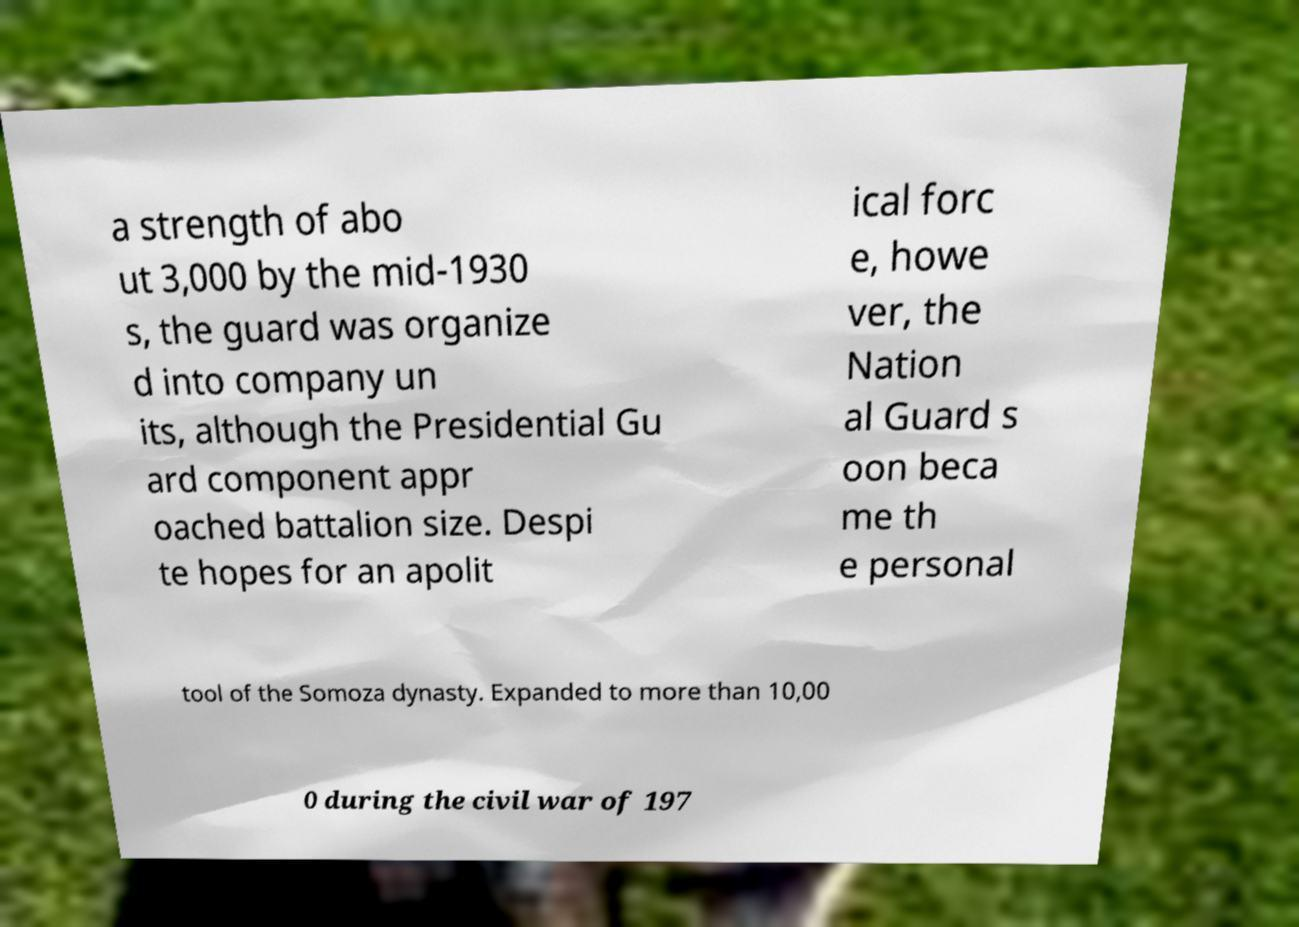Please read and relay the text visible in this image. What does it say? a strength of abo ut 3,000 by the mid-1930 s, the guard was organize d into company un its, although the Presidential Gu ard component appr oached battalion size. Despi te hopes for an apolit ical forc e, howe ver, the Nation al Guard s oon beca me th e personal tool of the Somoza dynasty. Expanded to more than 10,00 0 during the civil war of 197 